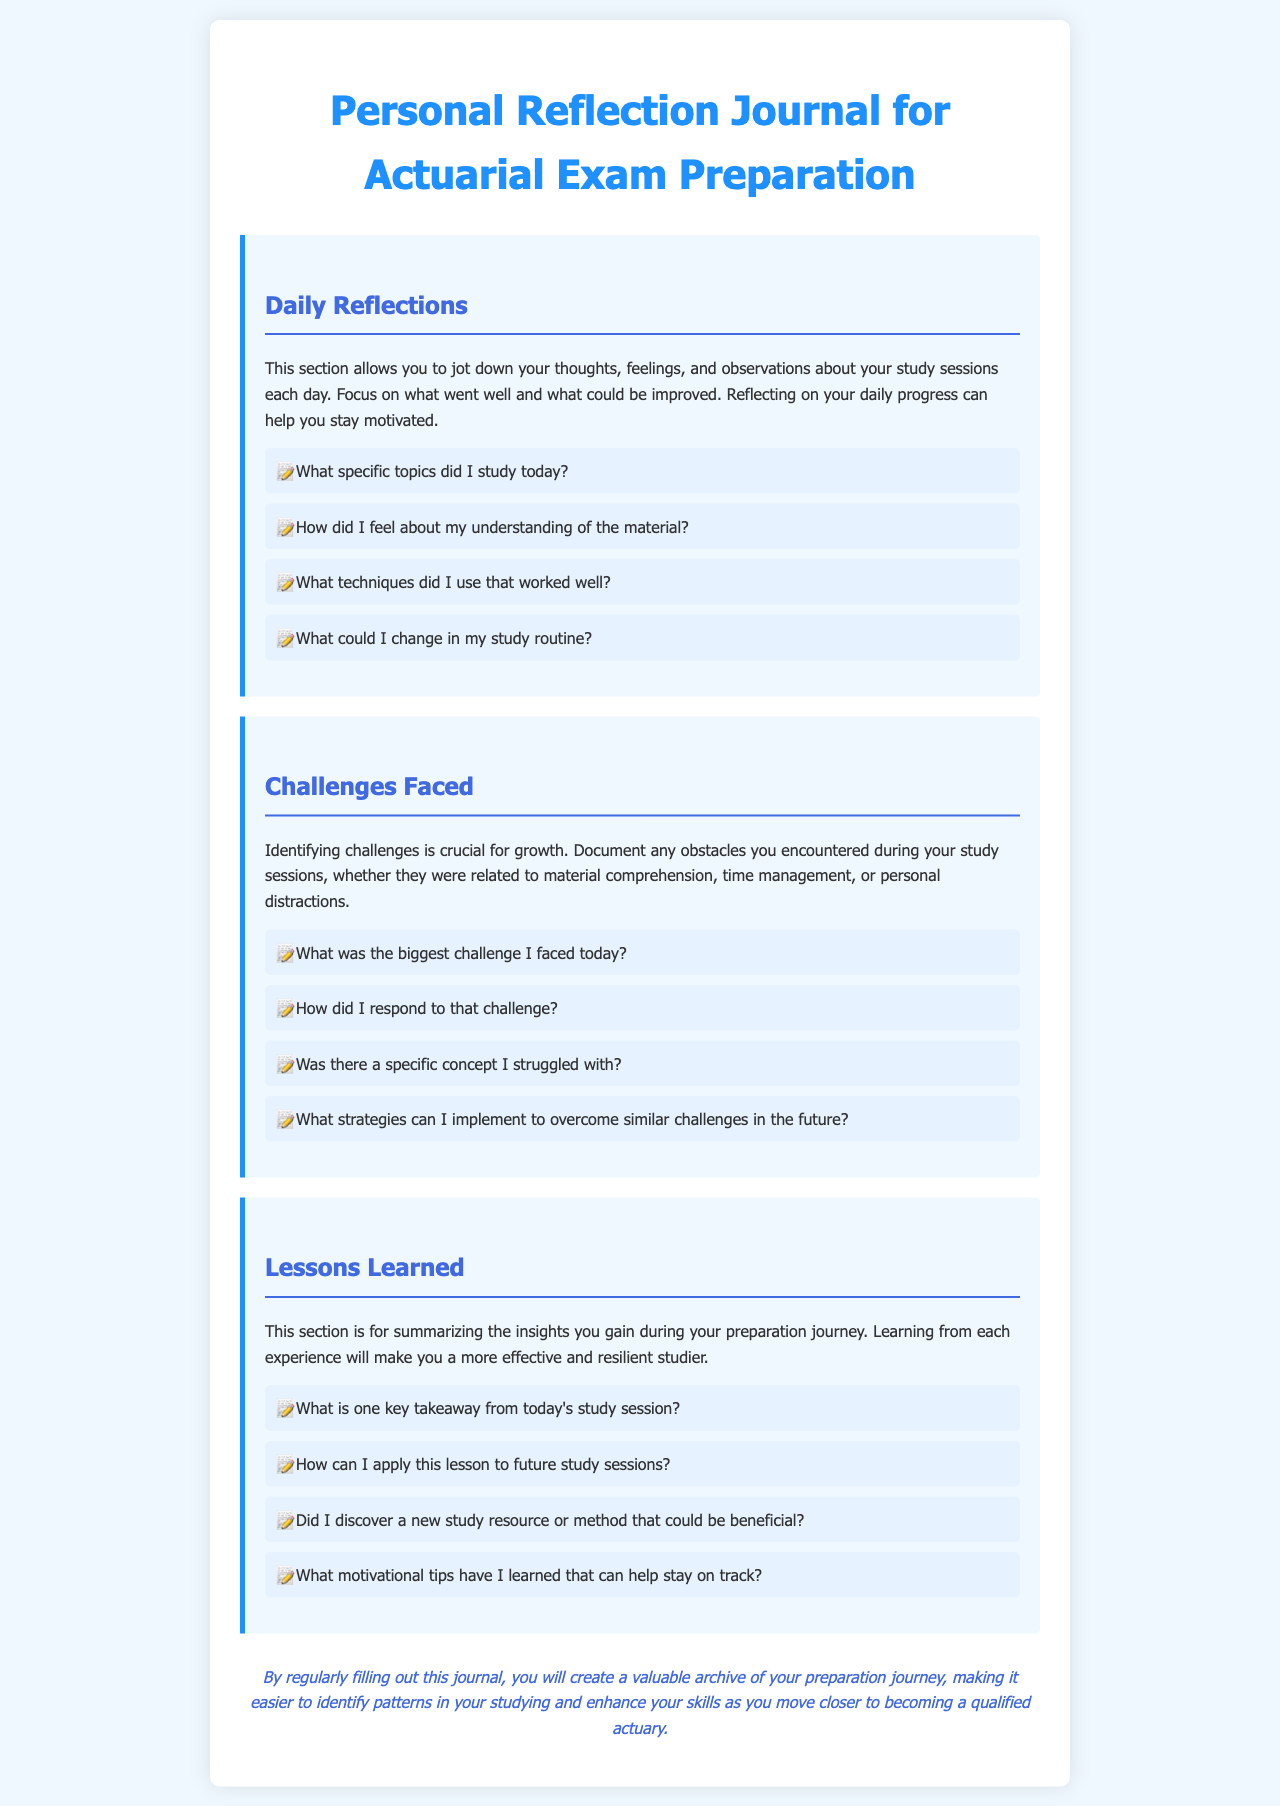What is the title of the journal? The title of the journal is stated at the top of the document, which outlines its purpose for preparation.
Answer: Personal Reflection Journal for Actuarial Exam Preparation What is the primary focus of the Daily Reflections section? The document explains the purpose of the Daily Reflections section, which helps track thoughts and feelings about study sessions.
Answer: Thoughts, feelings, and observations What prompts are included in the Challenges Faced section? The document lists specific questions to guide the user in identifying challenges encountered during study sessions.
Answer: What was the biggest challenge I faced today? How many sections are there in the document? The document presents three distinct sections focused on different reflections related to studying.
Answer: Three What is one key takeaway suggested in the Lessons Learned section? There is an emphasis on deriving actionable insights from each study session to enhance future preparation.
Answer: One key takeaway from today's study session Why is reflecting daily beneficial according to the journal? The journal suggests that regular reflections can enhance motivation and identify patterns in studying for better skills.
Answer: Stay motivated How does the journal encourage overcoming challenges? The journal prompts users to think about responses to difficulties, indicating strategies for future improvement.
Answer: Strategies to overcome similar challenges What color is used for the section headers in the document? The document describes a specific color format for section headers contributing to the visual layout.
Answer: #4169e1 Which style is used for the body text? The document specifies the font used for the main body of the text, contributing to readability.
Answer: 'Segoe UI', Tahoma, Geneva, Verdana, sans-serif 